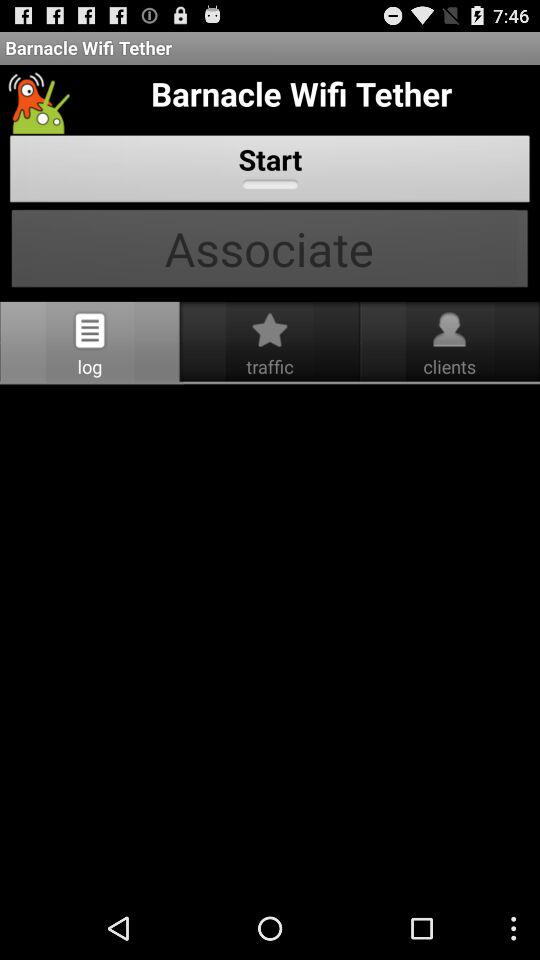What is the application name? The application name is "Barnacle Wifi Tether". 